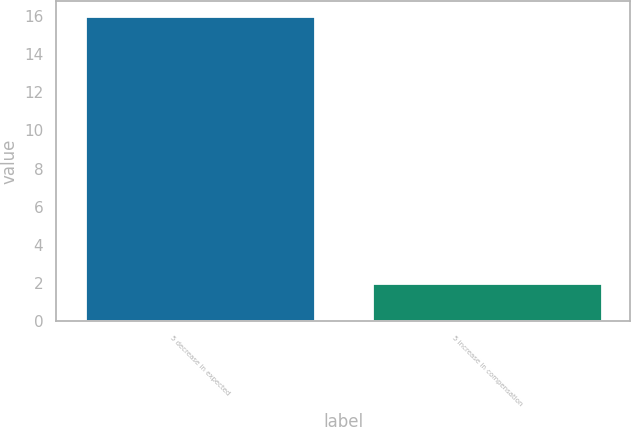Convert chart. <chart><loc_0><loc_0><loc_500><loc_500><bar_chart><fcel>5 decrease in expected<fcel>5 increase in compensation<nl><fcel>16<fcel>2<nl></chart> 